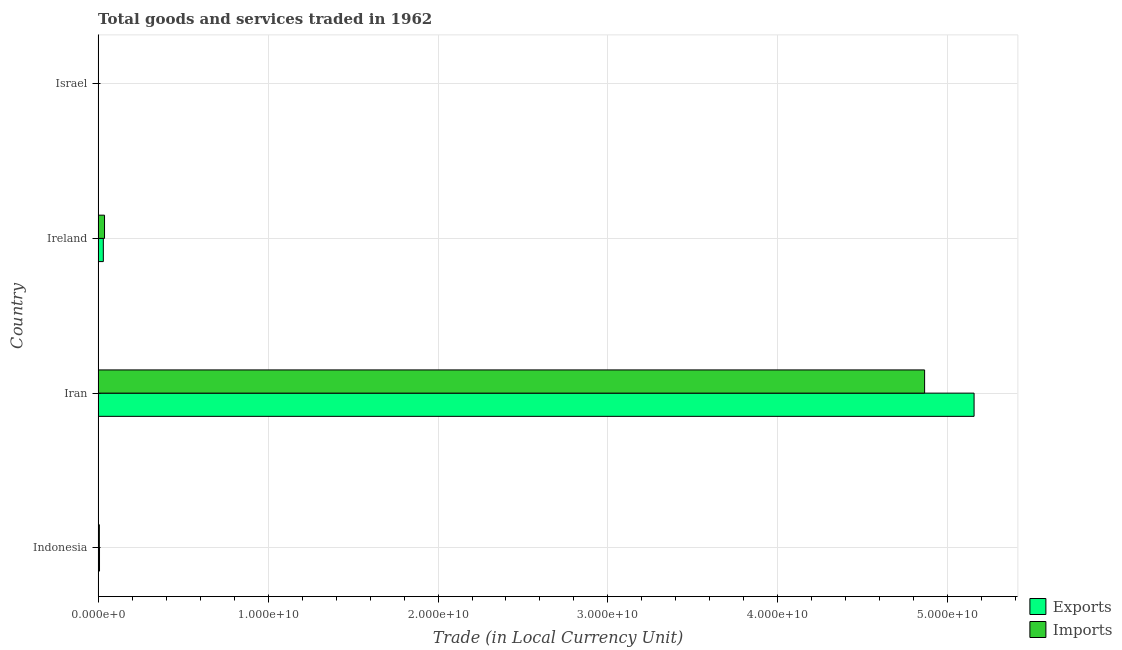How many different coloured bars are there?
Your answer should be very brief. 2. How many groups of bars are there?
Offer a terse response. 4. Are the number of bars on each tick of the Y-axis equal?
Offer a very short reply. Yes. How many bars are there on the 4th tick from the top?
Provide a short and direct response. 2. How many bars are there on the 3rd tick from the bottom?
Your answer should be very brief. 2. What is the label of the 3rd group of bars from the top?
Ensure brevity in your answer.  Iran. What is the export of goods and services in Iran?
Your answer should be compact. 5.15e+1. Across all countries, what is the maximum export of goods and services?
Provide a short and direct response. 5.15e+1. Across all countries, what is the minimum imports of goods and services?
Offer a very short reply. 1.26e+05. In which country was the export of goods and services maximum?
Ensure brevity in your answer.  Iran. In which country was the imports of goods and services minimum?
Your response must be concise. Israel. What is the total export of goods and services in the graph?
Your answer should be compact. 5.19e+1. What is the difference between the export of goods and services in Iran and that in Ireland?
Your answer should be compact. 5.12e+1. What is the difference between the export of goods and services in Israel and the imports of goods and services in Indonesia?
Offer a very short reply. -7.19e+07. What is the average imports of goods and services per country?
Keep it short and to the point. 1.23e+1. What is the difference between the imports of goods and services and export of goods and services in Ireland?
Ensure brevity in your answer.  7.10e+07. What is the ratio of the imports of goods and services in Iran to that in Israel?
Provide a short and direct response. 3.86e+05. What is the difference between the highest and the second highest imports of goods and services?
Make the answer very short. 4.83e+1. What is the difference between the highest and the lowest imports of goods and services?
Offer a terse response. 4.86e+1. Is the sum of the imports of goods and services in Ireland and Israel greater than the maximum export of goods and services across all countries?
Your answer should be very brief. No. What does the 1st bar from the top in Iran represents?
Keep it short and to the point. Imports. What does the 1st bar from the bottom in Israel represents?
Your answer should be compact. Exports. How many bars are there?
Give a very brief answer. 8. How many countries are there in the graph?
Provide a succinct answer. 4. Are the values on the major ticks of X-axis written in scientific E-notation?
Make the answer very short. Yes. How many legend labels are there?
Your answer should be compact. 2. What is the title of the graph?
Your answer should be very brief. Total goods and services traded in 1962. Does "Study and work" appear as one of the legend labels in the graph?
Offer a terse response. No. What is the label or title of the X-axis?
Offer a very short reply. Trade (in Local Currency Unit). What is the Trade (in Local Currency Unit) of Exports in Indonesia?
Your answer should be very brief. 8.19e+07. What is the Trade (in Local Currency Unit) of Imports in Indonesia?
Make the answer very short. 7.20e+07. What is the Trade (in Local Currency Unit) in Exports in Iran?
Provide a succinct answer. 5.15e+1. What is the Trade (in Local Currency Unit) of Imports in Iran?
Keep it short and to the point. 4.86e+1. What is the Trade (in Local Currency Unit) of Exports in Ireland?
Offer a terse response. 3.07e+08. What is the Trade (in Local Currency Unit) in Imports in Ireland?
Offer a terse response. 3.78e+08. What is the Trade (in Local Currency Unit) of Exports in Israel?
Provide a succinct answer. 1.34e+05. What is the Trade (in Local Currency Unit) in Imports in Israel?
Ensure brevity in your answer.  1.26e+05. Across all countries, what is the maximum Trade (in Local Currency Unit) of Exports?
Make the answer very short. 5.15e+1. Across all countries, what is the maximum Trade (in Local Currency Unit) of Imports?
Provide a succinct answer. 4.86e+1. Across all countries, what is the minimum Trade (in Local Currency Unit) in Exports?
Provide a succinct answer. 1.34e+05. Across all countries, what is the minimum Trade (in Local Currency Unit) of Imports?
Your response must be concise. 1.26e+05. What is the total Trade (in Local Currency Unit) in Exports in the graph?
Your answer should be very brief. 5.19e+1. What is the total Trade (in Local Currency Unit) in Imports in the graph?
Make the answer very short. 4.91e+1. What is the difference between the Trade (in Local Currency Unit) of Exports in Indonesia and that in Iran?
Give a very brief answer. -5.15e+1. What is the difference between the Trade (in Local Currency Unit) of Imports in Indonesia and that in Iran?
Keep it short and to the point. -4.86e+1. What is the difference between the Trade (in Local Currency Unit) in Exports in Indonesia and that in Ireland?
Provide a succinct answer. -2.25e+08. What is the difference between the Trade (in Local Currency Unit) of Imports in Indonesia and that in Ireland?
Make the answer very short. -3.06e+08. What is the difference between the Trade (in Local Currency Unit) of Exports in Indonesia and that in Israel?
Your answer should be compact. 8.18e+07. What is the difference between the Trade (in Local Currency Unit) of Imports in Indonesia and that in Israel?
Ensure brevity in your answer.  7.19e+07. What is the difference between the Trade (in Local Currency Unit) in Exports in Iran and that in Ireland?
Keep it short and to the point. 5.12e+1. What is the difference between the Trade (in Local Currency Unit) in Imports in Iran and that in Ireland?
Your response must be concise. 4.83e+1. What is the difference between the Trade (in Local Currency Unit) in Exports in Iran and that in Israel?
Your answer should be compact. 5.15e+1. What is the difference between the Trade (in Local Currency Unit) of Imports in Iran and that in Israel?
Make the answer very short. 4.86e+1. What is the difference between the Trade (in Local Currency Unit) in Exports in Ireland and that in Israel?
Offer a very short reply. 3.06e+08. What is the difference between the Trade (in Local Currency Unit) in Imports in Ireland and that in Israel?
Offer a very short reply. 3.77e+08. What is the difference between the Trade (in Local Currency Unit) of Exports in Indonesia and the Trade (in Local Currency Unit) of Imports in Iran?
Keep it short and to the point. -4.86e+1. What is the difference between the Trade (in Local Currency Unit) in Exports in Indonesia and the Trade (in Local Currency Unit) in Imports in Ireland?
Provide a succinct answer. -2.96e+08. What is the difference between the Trade (in Local Currency Unit) in Exports in Indonesia and the Trade (in Local Currency Unit) in Imports in Israel?
Ensure brevity in your answer.  8.18e+07. What is the difference between the Trade (in Local Currency Unit) of Exports in Iran and the Trade (in Local Currency Unit) of Imports in Ireland?
Keep it short and to the point. 5.12e+1. What is the difference between the Trade (in Local Currency Unit) in Exports in Iran and the Trade (in Local Currency Unit) in Imports in Israel?
Make the answer very short. 5.15e+1. What is the difference between the Trade (in Local Currency Unit) in Exports in Ireland and the Trade (in Local Currency Unit) in Imports in Israel?
Ensure brevity in your answer.  3.06e+08. What is the average Trade (in Local Currency Unit) in Exports per country?
Make the answer very short. 1.30e+1. What is the average Trade (in Local Currency Unit) in Imports per country?
Provide a short and direct response. 1.23e+1. What is the difference between the Trade (in Local Currency Unit) in Exports and Trade (in Local Currency Unit) in Imports in Indonesia?
Offer a very short reply. 9.90e+06. What is the difference between the Trade (in Local Currency Unit) of Exports and Trade (in Local Currency Unit) of Imports in Iran?
Offer a very short reply. 2.91e+09. What is the difference between the Trade (in Local Currency Unit) in Exports and Trade (in Local Currency Unit) in Imports in Ireland?
Your answer should be very brief. -7.10e+07. What is the difference between the Trade (in Local Currency Unit) in Exports and Trade (in Local Currency Unit) in Imports in Israel?
Keep it short and to the point. 8000. What is the ratio of the Trade (in Local Currency Unit) in Exports in Indonesia to that in Iran?
Your answer should be very brief. 0. What is the ratio of the Trade (in Local Currency Unit) in Imports in Indonesia to that in Iran?
Ensure brevity in your answer.  0. What is the ratio of the Trade (in Local Currency Unit) in Exports in Indonesia to that in Ireland?
Offer a terse response. 0.27. What is the ratio of the Trade (in Local Currency Unit) in Imports in Indonesia to that in Ireland?
Provide a short and direct response. 0.19. What is the ratio of the Trade (in Local Currency Unit) of Exports in Indonesia to that in Israel?
Your answer should be compact. 611.22. What is the ratio of the Trade (in Local Currency Unit) of Imports in Indonesia to that in Israel?
Make the answer very short. 571.43. What is the ratio of the Trade (in Local Currency Unit) of Exports in Iran to that in Ireland?
Offer a terse response. 168.13. What is the ratio of the Trade (in Local Currency Unit) in Imports in Iran to that in Ireland?
Make the answer very short. 128.79. What is the ratio of the Trade (in Local Currency Unit) of Exports in Iran to that in Israel?
Your answer should be compact. 3.85e+05. What is the ratio of the Trade (in Local Currency Unit) of Imports in Iran to that in Israel?
Your answer should be compact. 3.86e+05. What is the ratio of the Trade (in Local Currency Unit) of Exports in Ireland to that in Israel?
Your answer should be compact. 2287.81. What is the ratio of the Trade (in Local Currency Unit) in Imports in Ireland to that in Israel?
Make the answer very short. 2996.88. What is the difference between the highest and the second highest Trade (in Local Currency Unit) of Exports?
Keep it short and to the point. 5.12e+1. What is the difference between the highest and the second highest Trade (in Local Currency Unit) in Imports?
Offer a terse response. 4.83e+1. What is the difference between the highest and the lowest Trade (in Local Currency Unit) in Exports?
Give a very brief answer. 5.15e+1. What is the difference between the highest and the lowest Trade (in Local Currency Unit) of Imports?
Your response must be concise. 4.86e+1. 